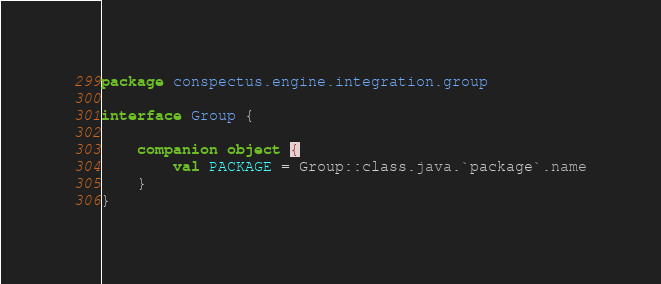<code> <loc_0><loc_0><loc_500><loc_500><_Kotlin_>package conspectus.engine.integration.group

interface Group {

    companion object {
        val PACKAGE = Group::class.java.`package`.name
    }
}</code> 